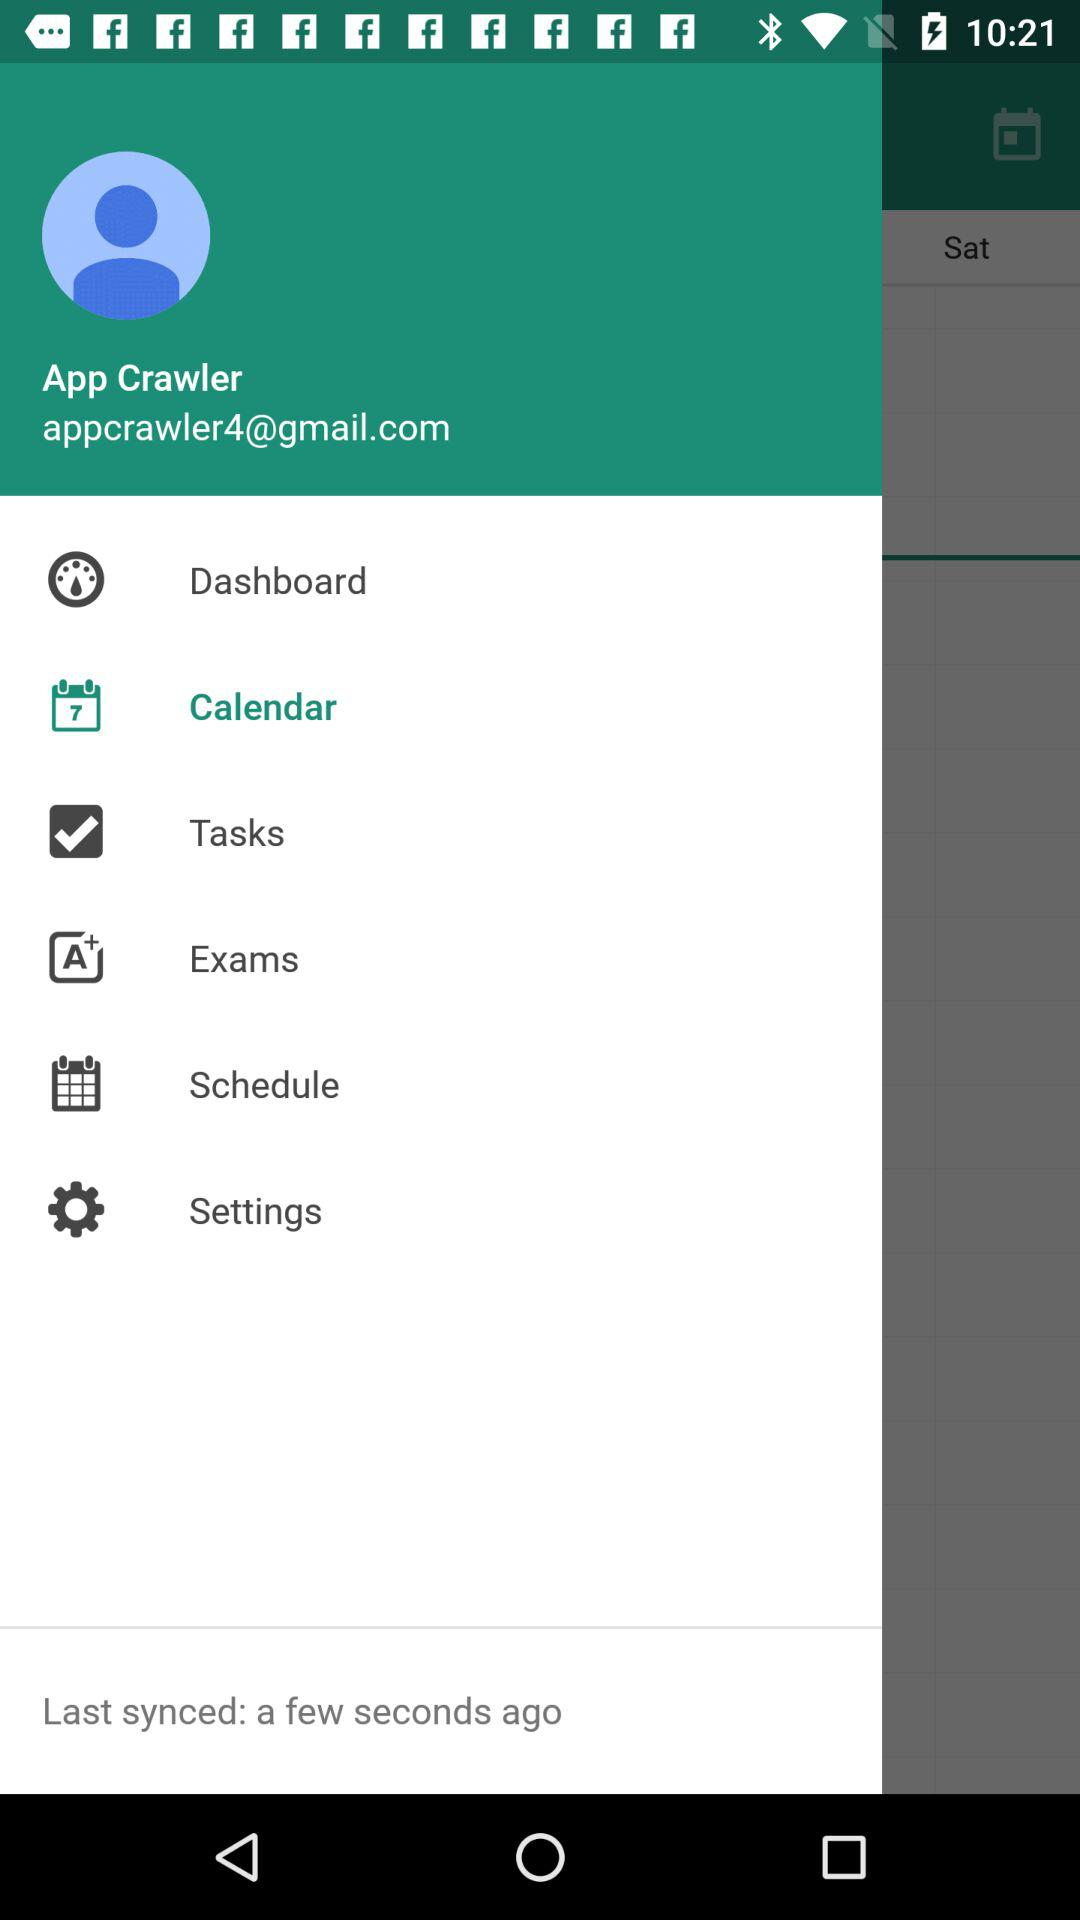When was it last synced? It was last synced a few seconds ago. 